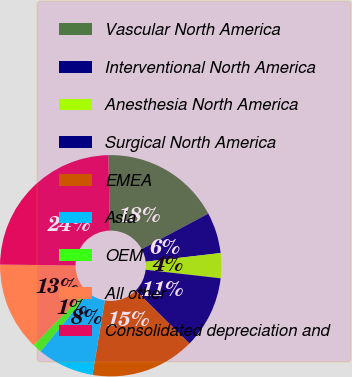Convert chart to OTSL. <chart><loc_0><loc_0><loc_500><loc_500><pie_chart><fcel>Vascular North America<fcel>Interventional North America<fcel>Anesthesia North America<fcel>Surgical North America<fcel>EMEA<fcel>Asia<fcel>OEM<fcel>All other<fcel>Consolidated depreciation and<nl><fcel>17.54%<fcel>5.97%<fcel>3.65%<fcel>10.6%<fcel>15.23%<fcel>8.28%<fcel>1.34%<fcel>12.91%<fcel>24.49%<nl></chart> 